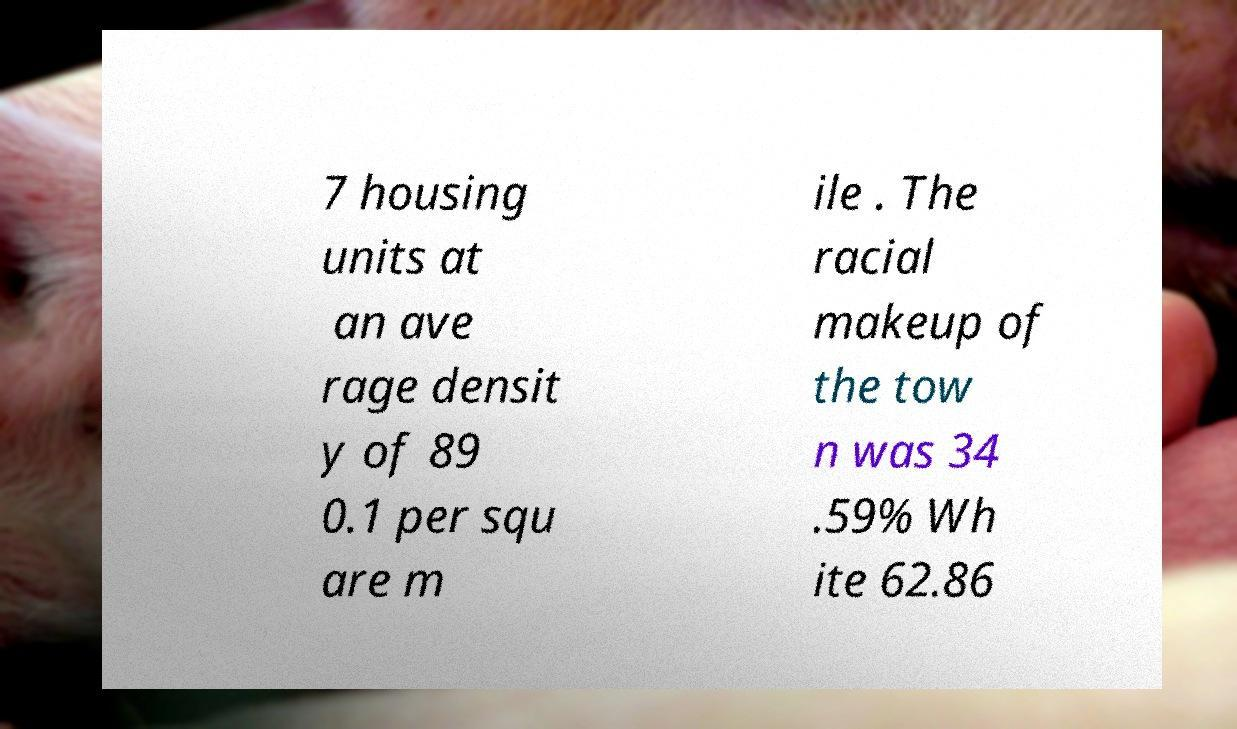Could you extract and type out the text from this image? 7 housing units at an ave rage densit y of 89 0.1 per squ are m ile . The racial makeup of the tow n was 34 .59% Wh ite 62.86 